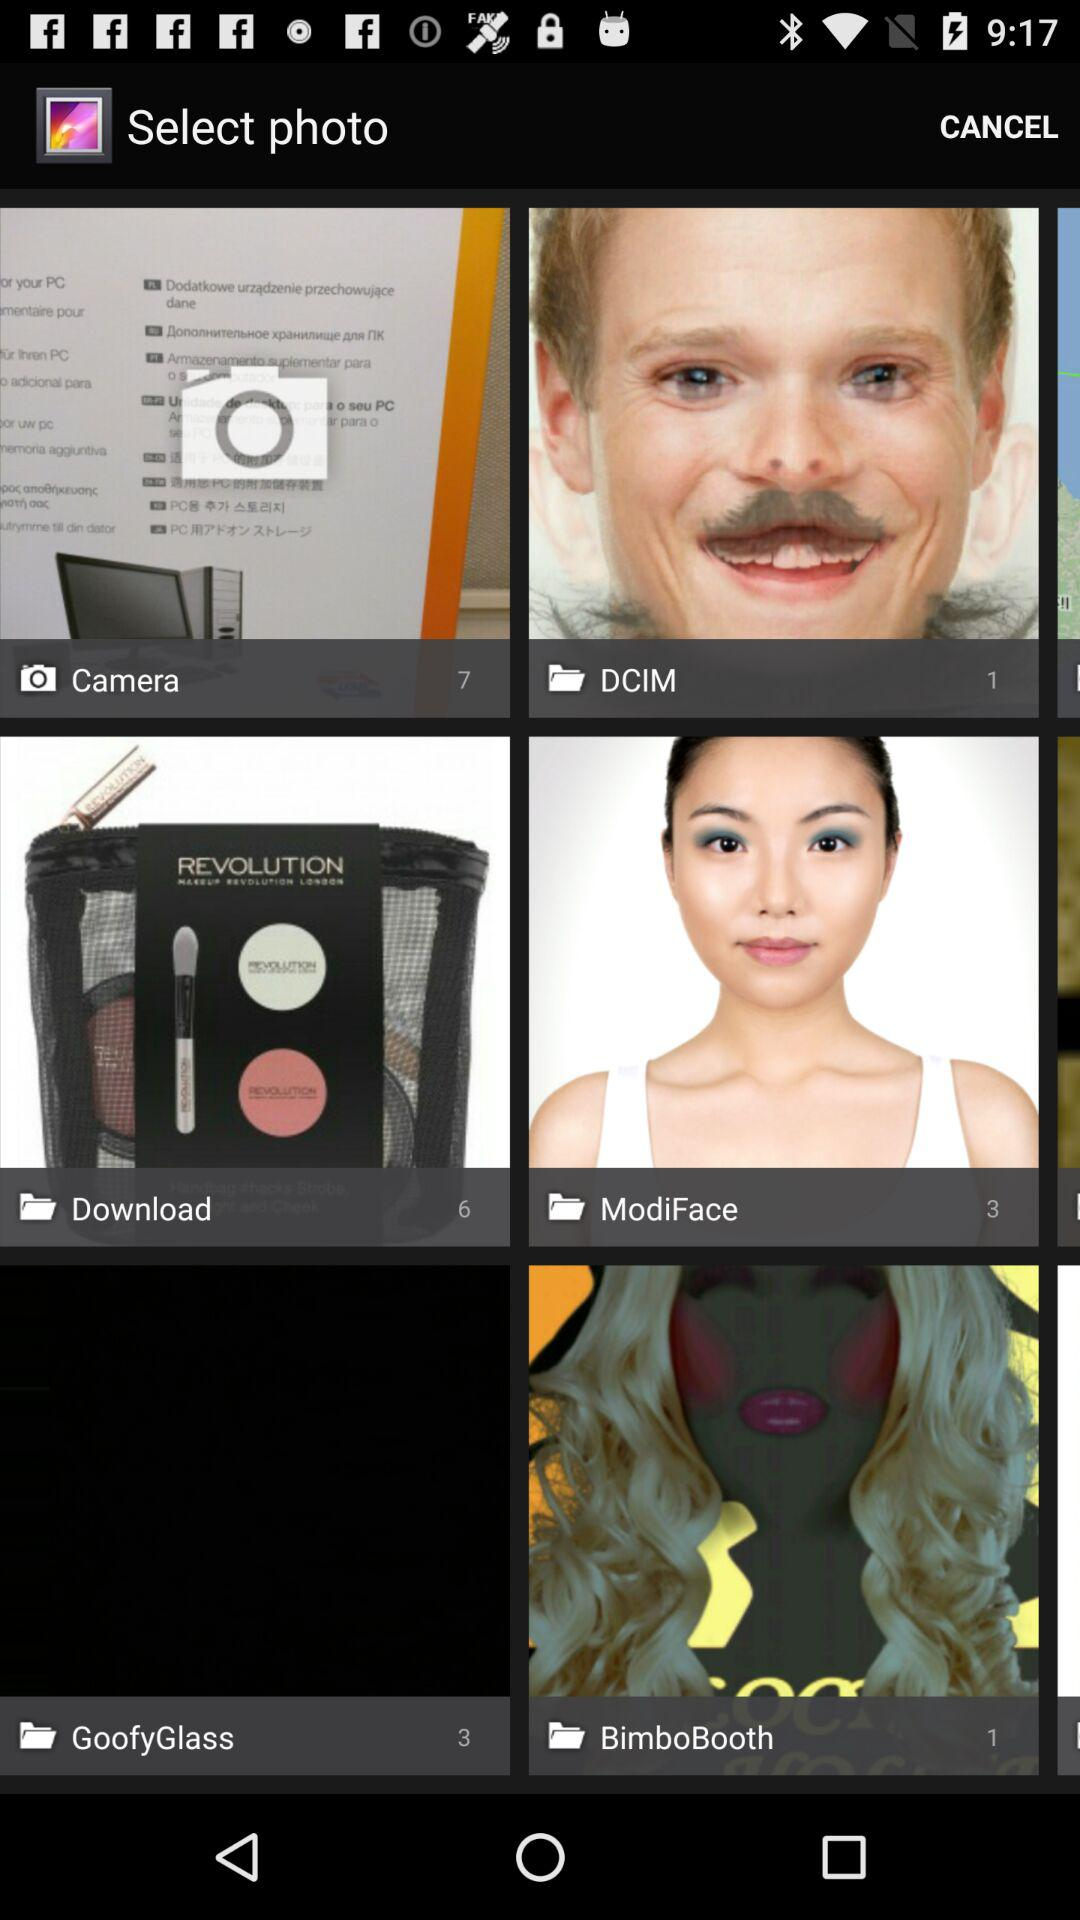How many photos are in "Download"? There are 6 photos in "Download". 